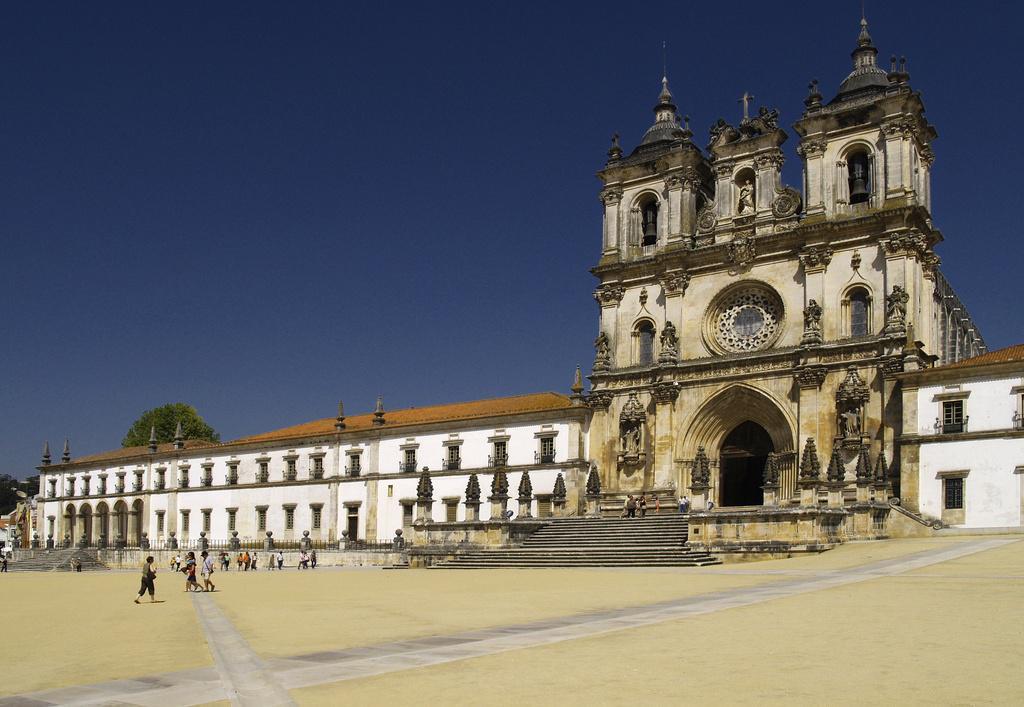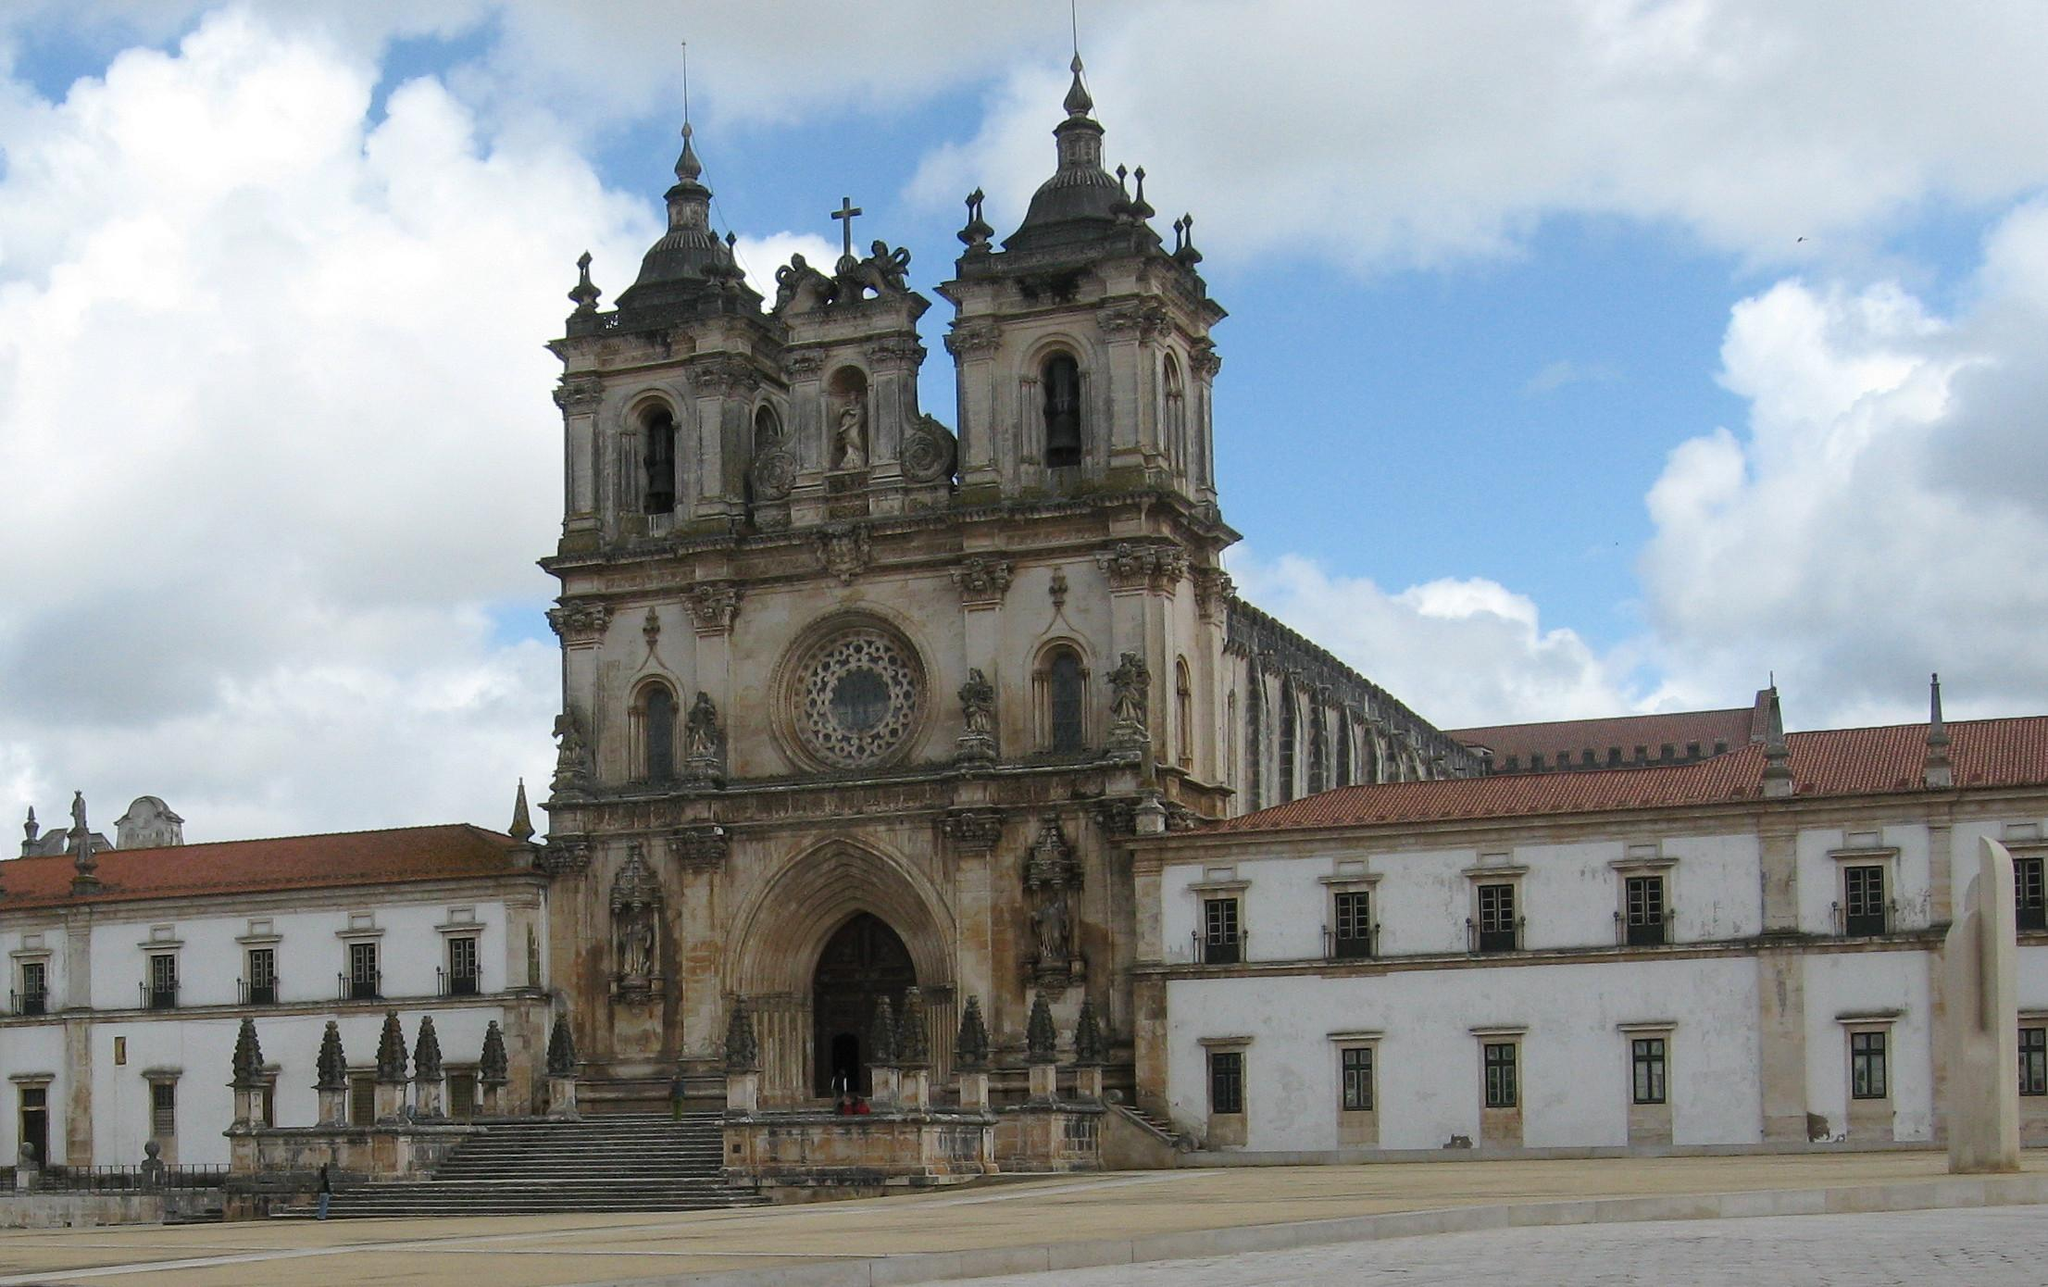The first image is the image on the left, the second image is the image on the right. Considering the images on both sides, is "Both buildings share the same design." valid? Answer yes or no. Yes. 